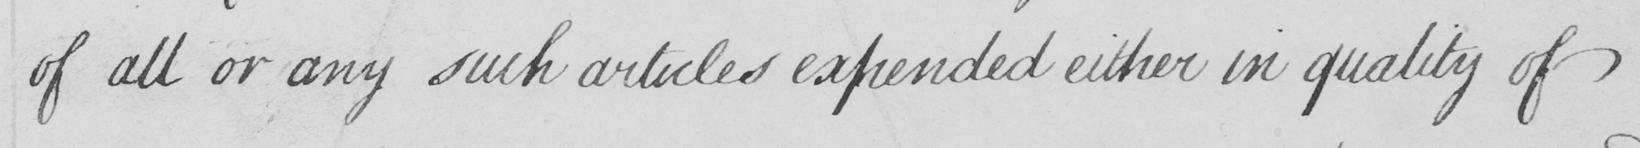Can you read and transcribe this handwriting? of all or any such articles expended either in quality of 